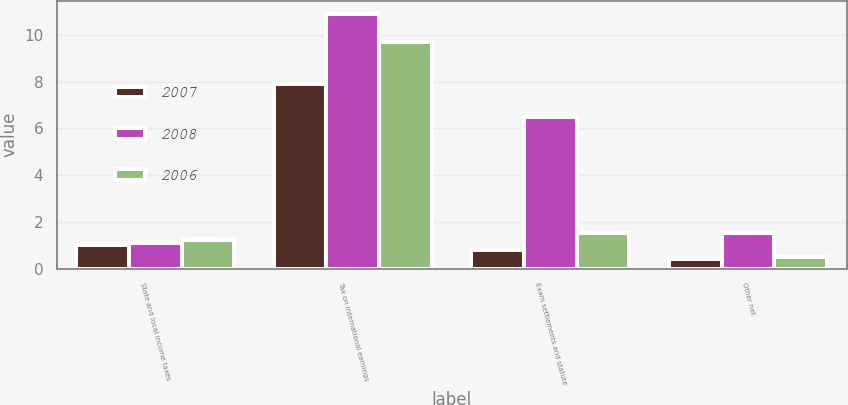Convert chart to OTSL. <chart><loc_0><loc_0><loc_500><loc_500><stacked_bar_chart><ecel><fcel>State and local income taxes<fcel>Tax on international earnings<fcel>Exam settlements and statute<fcel>Other net<nl><fcel>2007<fcel>1<fcel>7.9<fcel>0.8<fcel>0.4<nl><fcel>2008<fcel>1.1<fcel>10.9<fcel>6.5<fcel>1.5<nl><fcel>2006<fcel>1.2<fcel>9.7<fcel>1.5<fcel>0.5<nl></chart> 